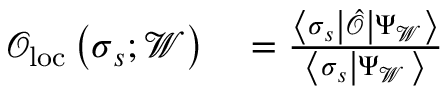<formula> <loc_0><loc_0><loc_500><loc_500>\begin{array} { r l } { \mathcal { O } _ { l o c } \left ( \sigma _ { s } ; \mathcal { W } \right ) } & = \frac { \left \langle \sigma _ { s } \left | \hat { \mathcal { O } } \right | \Psi _ { \mathcal { W } } \right \rangle } { \left \langle \sigma _ { s } \left | \Psi _ { \mathcal { W } } \right \rangle } } \end{array}</formula> 